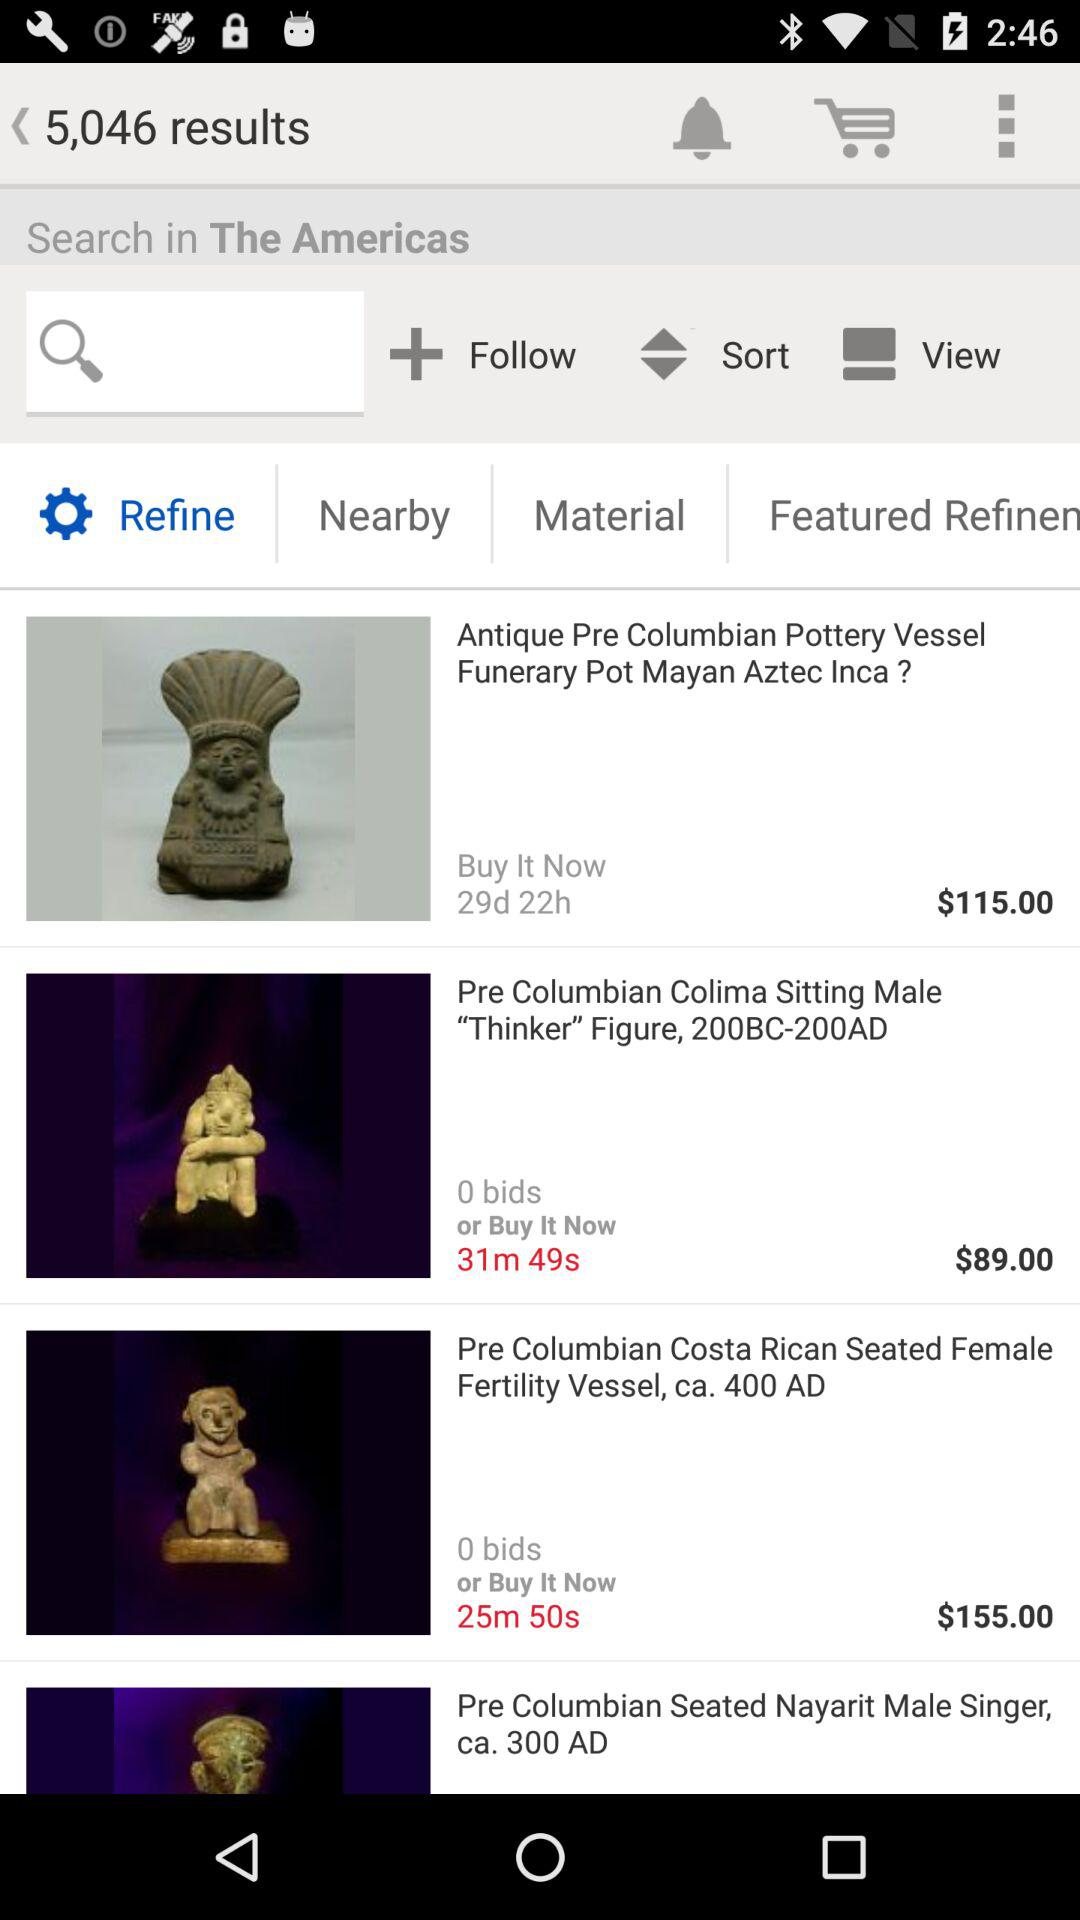What is the remaining auction time of "Pre Columbian Costa Rican Seated Female Fertility Vessel, ca. 400 AD"? The remaining auction time is 25 minutes and 50 seconds. 